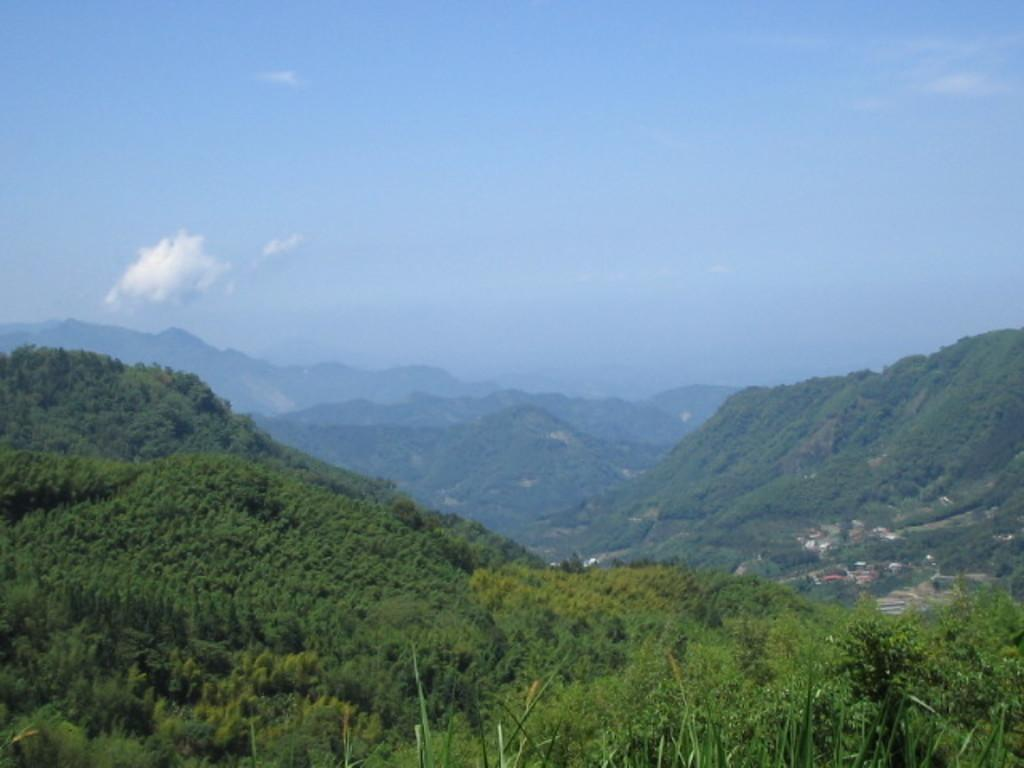What type of natural vegetation can be seen in the image? There are trees in the image. What type of location does the image depict? The image appears to depict a small village. What geographical feature is visible in the background of the image? There are mountains visible in the image. What is visible in the sky in the image? Clouds are present in the sky. What type of meat is being prepared on the wall in the image? There is no meat or wall present in the image; it features trees, a small village, mountains, and clouds. 